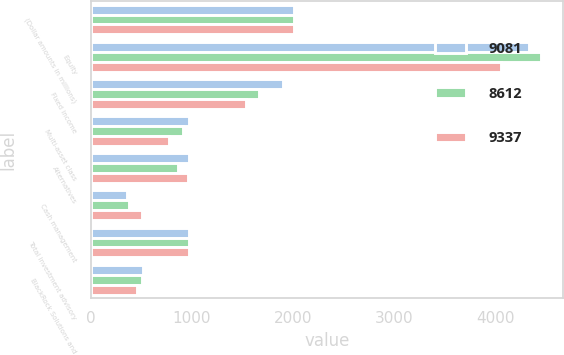Convert chart. <chart><loc_0><loc_0><loc_500><loc_500><stacked_bar_chart><ecel><fcel>(Dollar amounts in millions)<fcel>Equity<fcel>Fixed income<fcel>Multi-asset class<fcel>Alternatives<fcel>Cash management<fcel>Total investment advisory<fcel>BlackRock Solutions and<nl><fcel>9081<fcel>2012<fcel>4334<fcel>1900<fcel>972<fcel>968<fcel>361<fcel>968<fcel>518<nl><fcel>8612<fcel>2011<fcel>4447<fcel>1659<fcel>914<fcel>864<fcel>383<fcel>968<fcel>510<nl><fcel>9337<fcel>2010<fcel>4055<fcel>1531<fcel>773<fcel>961<fcel>510<fcel>968<fcel>460<nl></chart> 